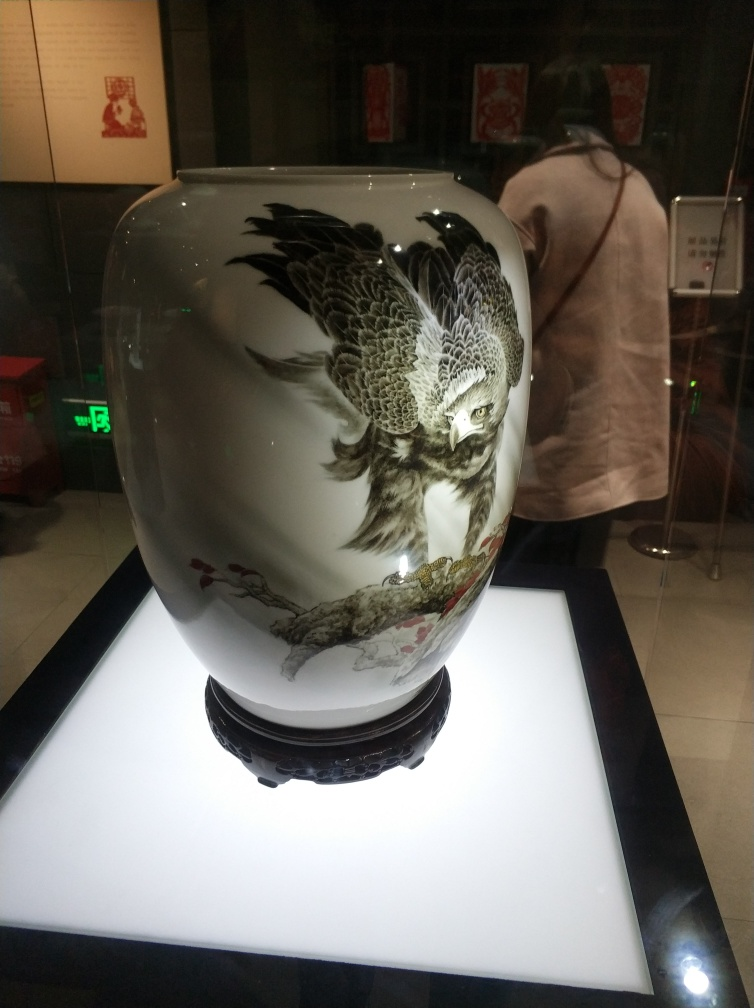What cultural significance might this type of vase have? Vases like this one often hold significant cultural value, serving both artistic and functional roles. They are commonly associated with prosperities, such as wealth and status, especially when intricately designed and prominently displayed. The owl might symbolize wisdom or protection in certain cultures. Originally, such vases may have been used in important ceremonies or gifted to honor individuals, and today, they frequently are collected as artistic or historical artifacts, cherished for their beauty and the skilled technique required to create them. 